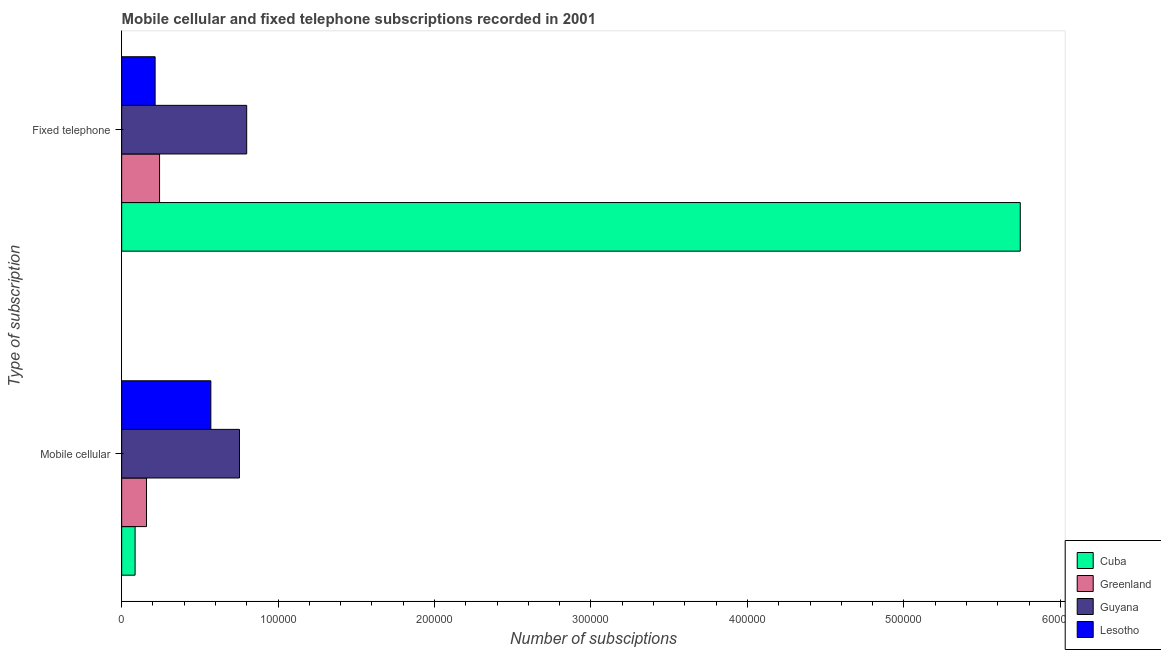Are the number of bars per tick equal to the number of legend labels?
Your answer should be very brief. Yes. Are the number of bars on each tick of the Y-axis equal?
Provide a succinct answer. Yes. How many bars are there on the 2nd tick from the top?
Your answer should be compact. 4. How many bars are there on the 1st tick from the bottom?
Your answer should be very brief. 4. What is the label of the 1st group of bars from the top?
Make the answer very short. Fixed telephone. What is the number of mobile cellular subscriptions in Guyana?
Make the answer very short. 7.53e+04. Across all countries, what is the maximum number of mobile cellular subscriptions?
Provide a succinct answer. 7.53e+04. Across all countries, what is the minimum number of mobile cellular subscriptions?
Your answer should be very brief. 8579. In which country was the number of mobile cellular subscriptions maximum?
Offer a terse response. Guyana. In which country was the number of fixed telephone subscriptions minimum?
Offer a terse response. Lesotho. What is the total number of mobile cellular subscriptions in the graph?
Keep it short and to the point. 1.57e+05. What is the difference between the number of fixed telephone subscriptions in Guyana and that in Greenland?
Your answer should be compact. 5.57e+04. What is the difference between the number of fixed telephone subscriptions in Cuba and the number of mobile cellular subscriptions in Lesotho?
Keep it short and to the point. 5.17e+05. What is the average number of fixed telephone subscriptions per country?
Give a very brief answer. 1.75e+05. What is the difference between the number of fixed telephone subscriptions and number of mobile cellular subscriptions in Lesotho?
Give a very brief answer. -3.56e+04. What is the ratio of the number of fixed telephone subscriptions in Guyana to that in Cuba?
Keep it short and to the point. 0.14. What does the 3rd bar from the top in Mobile cellular represents?
Provide a short and direct response. Greenland. What does the 1st bar from the bottom in Mobile cellular represents?
Make the answer very short. Cuba. Are all the bars in the graph horizontal?
Your answer should be compact. Yes. How many countries are there in the graph?
Your response must be concise. 4. Does the graph contain any zero values?
Provide a succinct answer. No. Does the graph contain grids?
Ensure brevity in your answer.  No. How many legend labels are there?
Make the answer very short. 4. What is the title of the graph?
Provide a succinct answer. Mobile cellular and fixed telephone subscriptions recorded in 2001. What is the label or title of the X-axis?
Your response must be concise. Number of subsciptions. What is the label or title of the Y-axis?
Your answer should be compact. Type of subscription. What is the Number of subsciptions in Cuba in Mobile cellular?
Ensure brevity in your answer.  8579. What is the Number of subsciptions in Greenland in Mobile cellular?
Your answer should be very brief. 1.59e+04. What is the Number of subsciptions in Guyana in Mobile cellular?
Ensure brevity in your answer.  7.53e+04. What is the Number of subsciptions of Lesotho in Mobile cellular?
Make the answer very short. 5.70e+04. What is the Number of subsciptions of Cuba in Fixed telephone?
Offer a terse response. 5.74e+05. What is the Number of subsciptions of Greenland in Fixed telephone?
Provide a short and direct response. 2.42e+04. What is the Number of subsciptions in Guyana in Fixed telephone?
Ensure brevity in your answer.  7.99e+04. What is the Number of subsciptions of Lesotho in Fixed telephone?
Your answer should be very brief. 2.14e+04. Across all Type of subscription, what is the maximum Number of subsciptions in Cuba?
Offer a very short reply. 5.74e+05. Across all Type of subscription, what is the maximum Number of subsciptions of Greenland?
Offer a terse response. 2.42e+04. Across all Type of subscription, what is the maximum Number of subsciptions of Guyana?
Offer a very short reply. 7.99e+04. Across all Type of subscription, what is the maximum Number of subsciptions of Lesotho?
Offer a very short reply. 5.70e+04. Across all Type of subscription, what is the minimum Number of subsciptions of Cuba?
Offer a terse response. 8579. Across all Type of subscription, what is the minimum Number of subsciptions in Greenland?
Keep it short and to the point. 1.59e+04. Across all Type of subscription, what is the minimum Number of subsciptions of Guyana?
Provide a short and direct response. 7.53e+04. Across all Type of subscription, what is the minimum Number of subsciptions in Lesotho?
Give a very brief answer. 2.14e+04. What is the total Number of subsciptions of Cuba in the graph?
Offer a very short reply. 5.83e+05. What is the total Number of subsciptions in Greenland in the graph?
Your answer should be compact. 4.01e+04. What is the total Number of subsciptions in Guyana in the graph?
Make the answer very short. 1.55e+05. What is the total Number of subsciptions of Lesotho in the graph?
Provide a succinct answer. 7.84e+04. What is the difference between the Number of subsciptions of Cuba in Mobile cellular and that in Fixed telephone?
Offer a very short reply. -5.66e+05. What is the difference between the Number of subsciptions of Greenland in Mobile cellular and that in Fixed telephone?
Ensure brevity in your answer.  -8335. What is the difference between the Number of subsciptions in Guyana in Mobile cellular and that in Fixed telephone?
Give a very brief answer. -4593. What is the difference between the Number of subsciptions in Lesotho in Mobile cellular and that in Fixed telephone?
Your response must be concise. 3.56e+04. What is the difference between the Number of subsciptions of Cuba in Mobile cellular and the Number of subsciptions of Greenland in Fixed telephone?
Make the answer very short. -1.56e+04. What is the difference between the Number of subsciptions of Cuba in Mobile cellular and the Number of subsciptions of Guyana in Fixed telephone?
Give a very brief answer. -7.13e+04. What is the difference between the Number of subsciptions in Cuba in Mobile cellular and the Number of subsciptions in Lesotho in Fixed telephone?
Your response must be concise. -1.28e+04. What is the difference between the Number of subsciptions of Greenland in Mobile cellular and the Number of subsciptions of Guyana in Fixed telephone?
Offer a very short reply. -6.40e+04. What is the difference between the Number of subsciptions of Greenland in Mobile cellular and the Number of subsciptions of Lesotho in Fixed telephone?
Offer a very short reply. -5500. What is the difference between the Number of subsciptions of Guyana in Mobile cellular and the Number of subsciptions of Lesotho in Fixed telephone?
Your response must be concise. 5.39e+04. What is the average Number of subsciptions of Cuba per Type of subscription?
Your response must be concise. 2.91e+05. What is the average Number of subsciptions in Greenland per Type of subscription?
Your answer should be compact. 2.00e+04. What is the average Number of subsciptions in Guyana per Type of subscription?
Your answer should be compact. 7.76e+04. What is the average Number of subsciptions in Lesotho per Type of subscription?
Your answer should be very brief. 3.92e+04. What is the difference between the Number of subsciptions of Cuba and Number of subsciptions of Greenland in Mobile cellular?
Offer a terse response. -7303. What is the difference between the Number of subsciptions of Cuba and Number of subsciptions of Guyana in Mobile cellular?
Provide a succinct answer. -6.67e+04. What is the difference between the Number of subsciptions of Cuba and Number of subsciptions of Lesotho in Mobile cellular?
Your answer should be very brief. -4.84e+04. What is the difference between the Number of subsciptions of Greenland and Number of subsciptions of Guyana in Mobile cellular?
Provide a succinct answer. -5.94e+04. What is the difference between the Number of subsciptions in Greenland and Number of subsciptions in Lesotho in Mobile cellular?
Provide a succinct answer. -4.11e+04. What is the difference between the Number of subsciptions in Guyana and Number of subsciptions in Lesotho in Mobile cellular?
Keep it short and to the point. 1.83e+04. What is the difference between the Number of subsciptions in Cuba and Number of subsciptions in Greenland in Fixed telephone?
Your answer should be very brief. 5.50e+05. What is the difference between the Number of subsciptions of Cuba and Number of subsciptions of Guyana in Fixed telephone?
Make the answer very short. 4.95e+05. What is the difference between the Number of subsciptions of Cuba and Number of subsciptions of Lesotho in Fixed telephone?
Your response must be concise. 5.53e+05. What is the difference between the Number of subsciptions in Greenland and Number of subsciptions in Guyana in Fixed telephone?
Provide a short and direct response. -5.57e+04. What is the difference between the Number of subsciptions in Greenland and Number of subsciptions in Lesotho in Fixed telephone?
Provide a succinct answer. 2835. What is the difference between the Number of subsciptions of Guyana and Number of subsciptions of Lesotho in Fixed telephone?
Provide a succinct answer. 5.85e+04. What is the ratio of the Number of subsciptions of Cuba in Mobile cellular to that in Fixed telephone?
Provide a short and direct response. 0.01. What is the ratio of the Number of subsciptions of Greenland in Mobile cellular to that in Fixed telephone?
Provide a short and direct response. 0.66. What is the ratio of the Number of subsciptions in Guyana in Mobile cellular to that in Fixed telephone?
Ensure brevity in your answer.  0.94. What is the ratio of the Number of subsciptions of Lesotho in Mobile cellular to that in Fixed telephone?
Offer a very short reply. 2.67. What is the difference between the highest and the second highest Number of subsciptions in Cuba?
Your answer should be compact. 5.66e+05. What is the difference between the highest and the second highest Number of subsciptions of Greenland?
Your answer should be very brief. 8335. What is the difference between the highest and the second highest Number of subsciptions of Guyana?
Offer a very short reply. 4593. What is the difference between the highest and the second highest Number of subsciptions of Lesotho?
Offer a very short reply. 3.56e+04. What is the difference between the highest and the lowest Number of subsciptions in Cuba?
Offer a very short reply. 5.66e+05. What is the difference between the highest and the lowest Number of subsciptions of Greenland?
Your response must be concise. 8335. What is the difference between the highest and the lowest Number of subsciptions in Guyana?
Your response must be concise. 4593. What is the difference between the highest and the lowest Number of subsciptions of Lesotho?
Make the answer very short. 3.56e+04. 